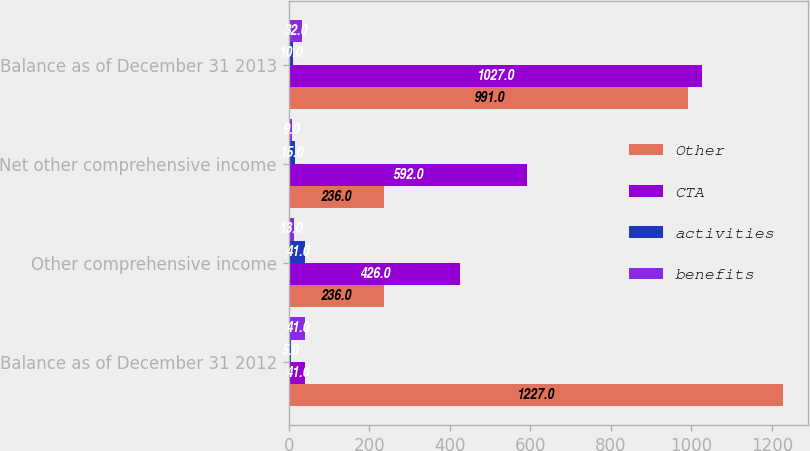Convert chart. <chart><loc_0><loc_0><loc_500><loc_500><stacked_bar_chart><ecel><fcel>Balance as of December 31 2012<fcel>Other comprehensive income<fcel>Net other comprehensive income<fcel>Balance as of December 31 2013<nl><fcel>Other<fcel>1227<fcel>236<fcel>236<fcel>991<nl><fcel>CTA<fcel>41<fcel>426<fcel>592<fcel>1027<nl><fcel>activities<fcel>5<fcel>41<fcel>15<fcel>10<nl><fcel>benefits<fcel>41<fcel>13<fcel>9<fcel>32<nl></chart> 